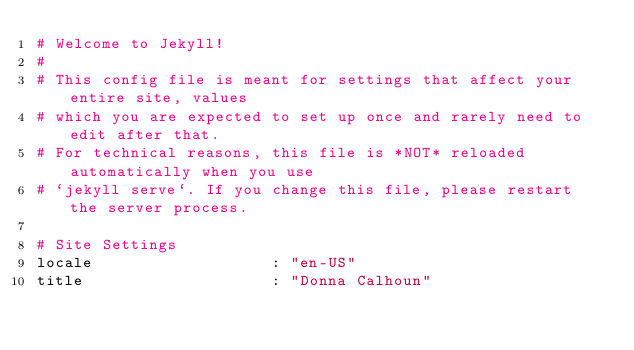<code> <loc_0><loc_0><loc_500><loc_500><_YAML_># Welcome to Jekyll!
#
# This config file is meant for settings that affect your entire site, values
# which you are expected to set up once and rarely need to edit after that.
# For technical reasons, this file is *NOT* reloaded automatically when you use
# `jekyll serve`. If you change this file, please restart the server process.

# Site Settings
locale                   : "en-US"
title                    : "Donna Calhoun"</code> 